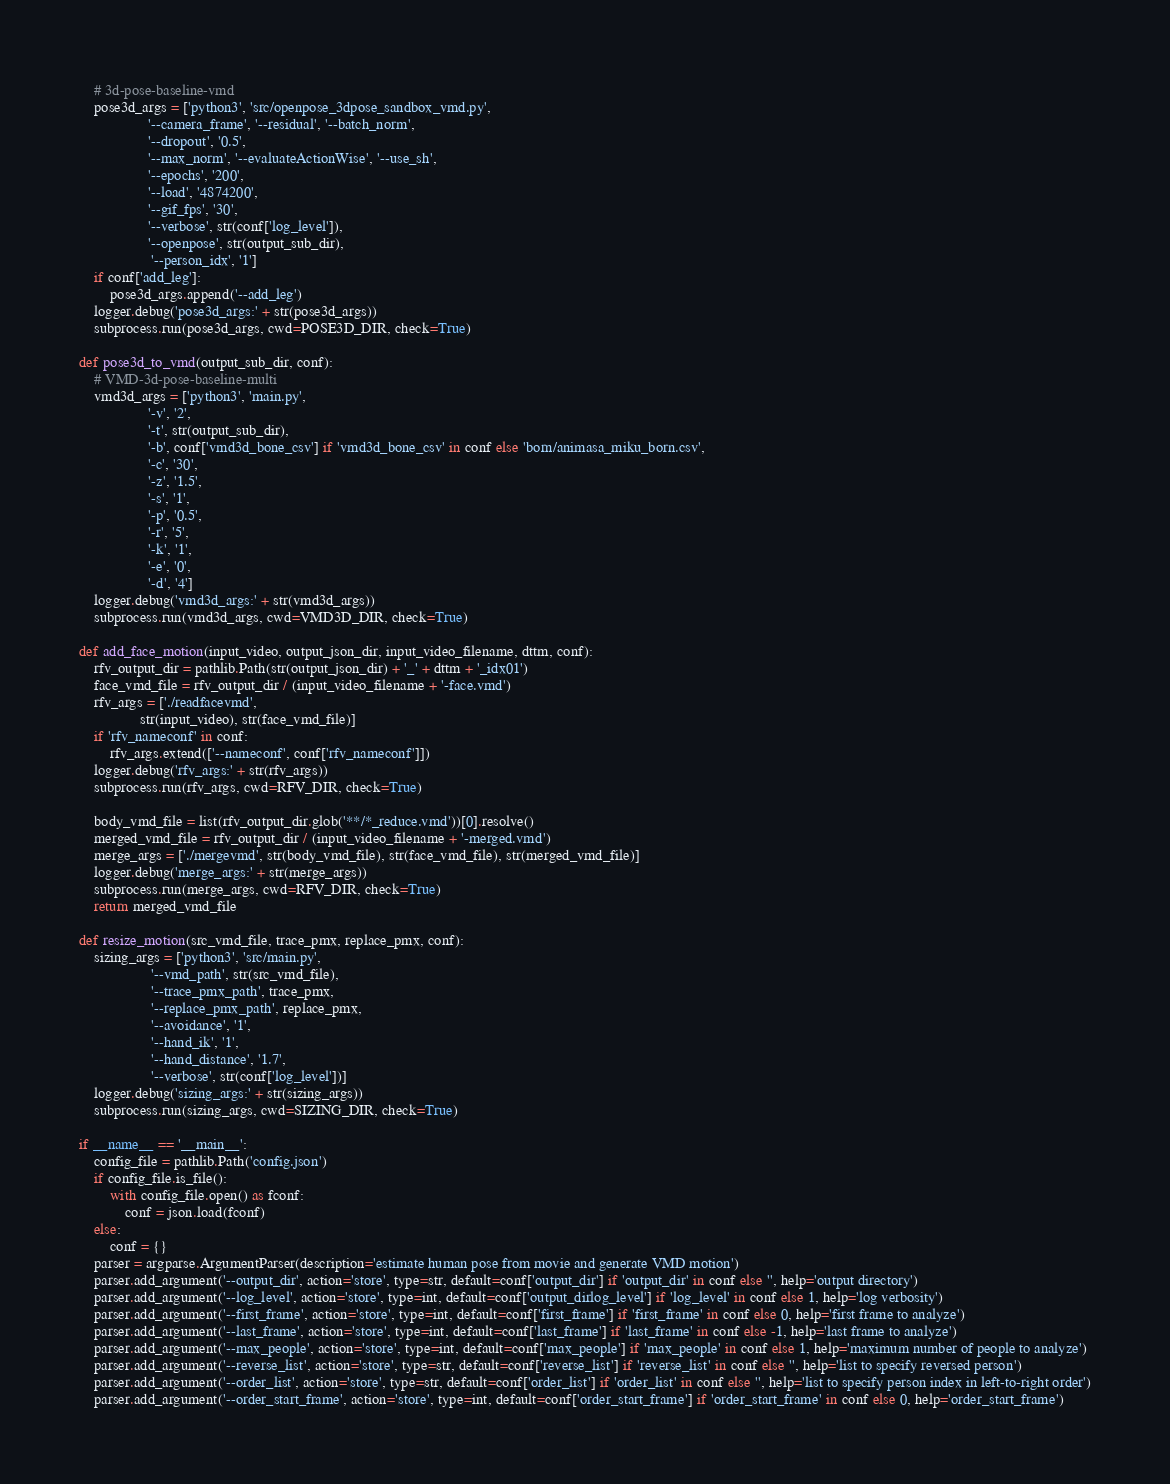<code> <loc_0><loc_0><loc_500><loc_500><_Python_>    # 3d-pose-baseline-vmd
    pose3d_args = ['python3', 'src/openpose_3dpose_sandbox_vmd.py',
                  '--camera_frame', '--residual', '--batch_norm',
                  '--dropout', '0.5',
                  '--max_norm', '--evaluateActionWise', '--use_sh',
                  '--epochs', '200',
                  '--load', '4874200',
                  '--gif_fps', '30',
                  '--verbose', str(conf['log_level']),
                  '--openpose', str(output_sub_dir),
                   '--person_idx', '1']
    if conf['add_leg']:
        pose3d_args.append('--add_leg')
    logger.debug('pose3d_args:' + str(pose3d_args))
    subprocess.run(pose3d_args, cwd=POSE3D_DIR, check=True)

def pose3d_to_vmd(output_sub_dir, conf):
    # VMD-3d-pose-baseline-multi
    vmd3d_args = ['python3', 'main.py',
                  '-v', '2',
                  '-t', str(output_sub_dir),
                  '-b', conf['vmd3d_bone_csv'] if 'vmd3d_bone_csv' in conf else 'born/animasa_miku_born.csv',
                  '-c', '30',
                  '-z', '1.5',
                  '-s', '1',
                  '-p', '0.5',
                  '-r', '5',
                  '-k', '1',
                  '-e', '0',
                  '-d', '4']
    logger.debug('vmd3d_args:' + str(vmd3d_args))
    subprocess.run(vmd3d_args, cwd=VMD3D_DIR, check=True)

def add_face_motion(input_video, output_json_dir, input_video_filename, dttm, conf):
    rfv_output_dir = pathlib.Path(str(output_json_dir) + '_' + dttm + '_idx01')
    face_vmd_file = rfv_output_dir / (input_video_filename + '-face.vmd')
    rfv_args = ['./readfacevmd',
                str(input_video), str(face_vmd_file)]
    if 'rfv_nameconf' in conf:
        rfv_args.extend(['--nameconf', conf['rfv_nameconf']])
    logger.debug('rfv_args:' + str(rfv_args))
    subprocess.run(rfv_args, cwd=RFV_DIR, check=True)

    body_vmd_file = list(rfv_output_dir.glob('**/*_reduce.vmd'))[0].resolve()
    merged_vmd_file = rfv_output_dir / (input_video_filename + '-merged.vmd')
    merge_args = ['./mergevmd', str(body_vmd_file), str(face_vmd_file), str(merged_vmd_file)]
    logger.debug('merge_args:' + str(merge_args))
    subprocess.run(merge_args, cwd=RFV_DIR, check=True)
    return merged_vmd_file

def resize_motion(src_vmd_file, trace_pmx, replace_pmx, conf):
    sizing_args = ['python3', 'src/main.py',
                   '--vmd_path', str(src_vmd_file),
                   '--trace_pmx_path', trace_pmx,
                   '--replace_pmx_path', replace_pmx,
                   '--avoidance', '1',
                   '--hand_ik', '1',
                   '--hand_distance', '1.7',
                   '--verbose', str(conf['log_level'])]
    logger.debug('sizing_args:' + str(sizing_args))
    subprocess.run(sizing_args, cwd=SIZING_DIR, check=True)

if __name__ == '__main__':
    config_file = pathlib.Path('config.json')
    if config_file.is_file():
        with config_file.open() as fconf:
            conf = json.load(fconf)
    else:
        conf = {}
    parser = argparse.ArgumentParser(description='estimate human pose from movie and generate VMD motion')
    parser.add_argument('--output_dir', action='store', type=str, default=conf['output_dir'] if 'output_dir' in conf else '', help='output directory')
    parser.add_argument('--log_level', action='store', type=int, default=conf['output_dirlog_level'] if 'log_level' in conf else 1, help='log verbosity')
    parser.add_argument('--first_frame', action='store', type=int, default=conf['first_frame'] if 'first_frame' in conf else 0, help='first frame to analyze')
    parser.add_argument('--last_frame', action='store', type=int, default=conf['last_frame'] if 'last_frame' in conf else -1, help='last frame to analyze')
    parser.add_argument('--max_people', action='store', type=int, default=conf['max_people'] if 'max_people' in conf else 1, help='maximum number of people to analyze')
    parser.add_argument('--reverse_list', action='store', type=str, default=conf['reverse_list'] if 'reverse_list' in conf else '', help='list to specify reversed person')
    parser.add_argument('--order_list', action='store', type=str, default=conf['order_list'] if 'order_list' in conf else '', help='list to specify person index in left-to-right order')
    parser.add_argument('--order_start_frame', action='store', type=int, default=conf['order_start_frame'] if 'order_start_frame' in conf else 0, help='order_start_frame')</code> 